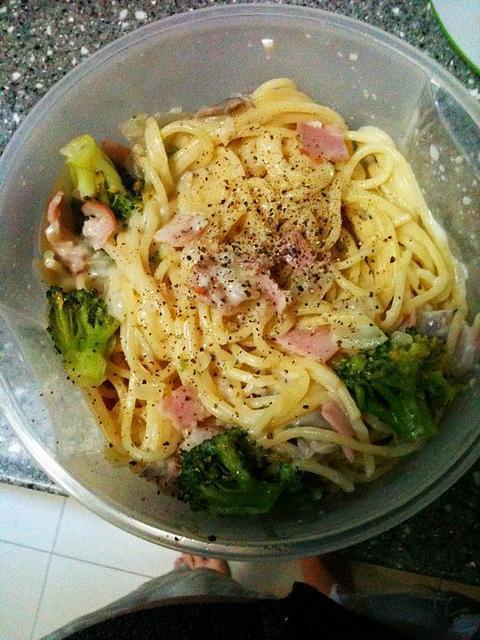How many broccolis can be seen?
Give a very brief answer. 4. 